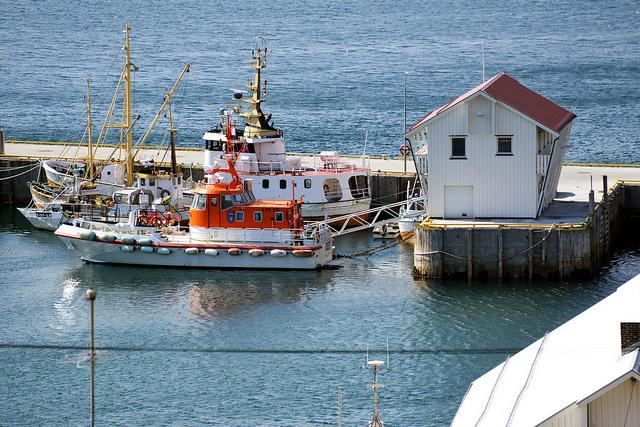What is above water? Please explain your reasoning. boat. The boat is above water. 